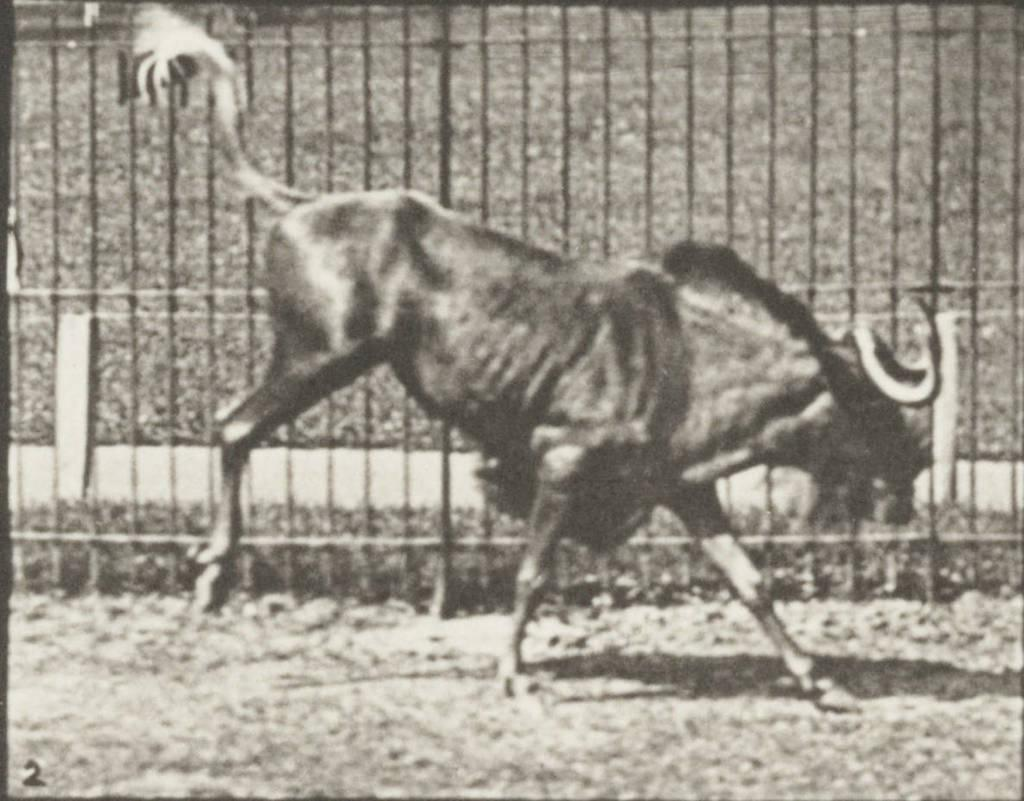What type of animal is in the image? The type of animal cannot be determined from the provided facts. What is surrounding the animal in the image? There is fencing around the animal in the image. Can you tell me how many teeth the animal has in the image? The number of teeth cannot be determined from the provided facts, as the type of animal is not specified. 